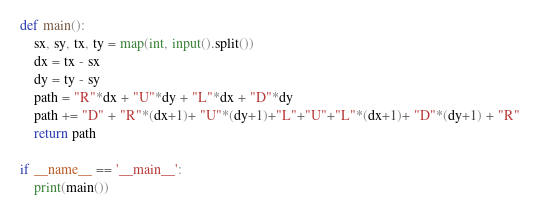<code> <loc_0><loc_0><loc_500><loc_500><_Python_>def main():
    sx, sy, tx, ty = map(int, input().split())
    dx = tx - sx
    dy = ty - sy
    path = "R"*dx + "U"*dy + "L"*dx + "D"*dy
    path += "D" + "R"*(dx+1)+ "U"*(dy+1)+"L"+"U"+"L"*(dx+1)+ "D"*(dy+1) + "R"
    return path

if __name__ == '__main__':
    print(main())</code> 